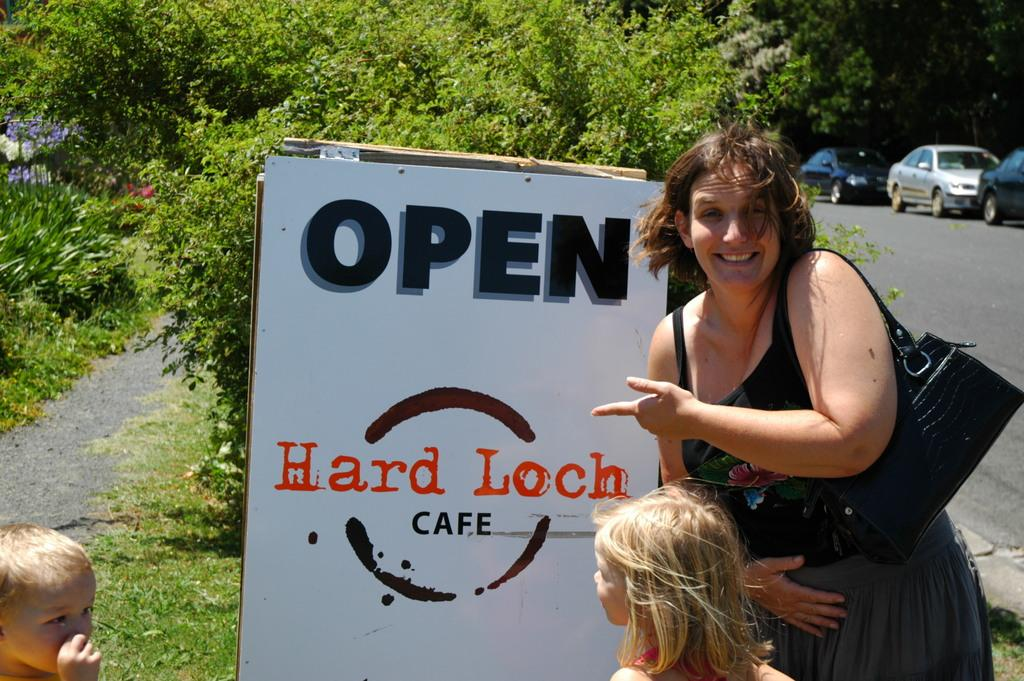How many people are present in the image? There are a boy, a girl, and a woman in the image. What can be seen on the name board in the image? The image appears to have a name board, but the specific details on it cannot be determined. What type of vegetation is visible in the image? There are small plants and trees in the image. How many cars are parked beside the road in the image? There are three cars parked beside the road in the image. What is the price of the water bottle in the image? There is no water bottle present in the image, so it is not possible to determine its price. 